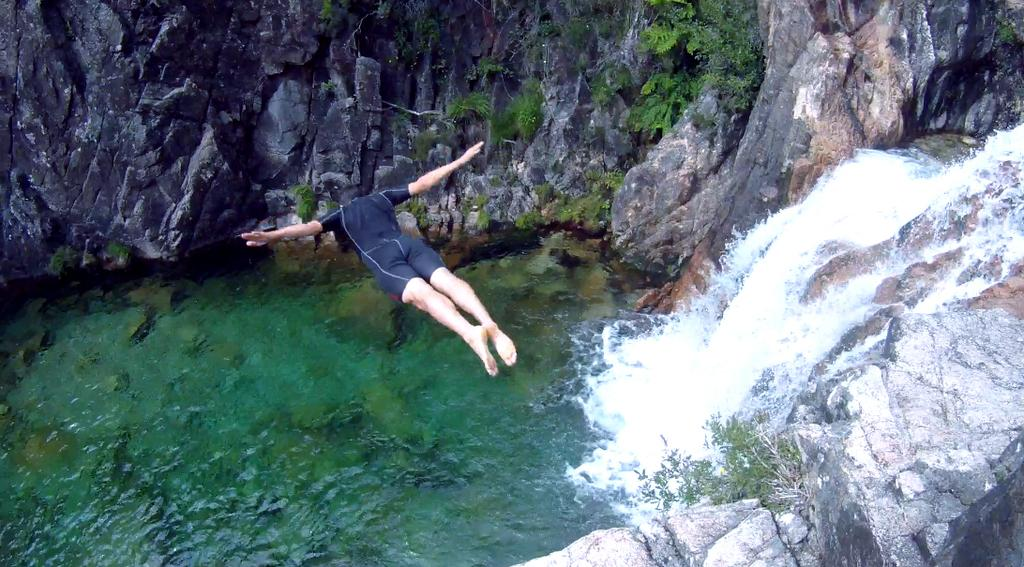What natural feature is the main subject of the image? There is a waterfall in the image. What type of geological formation can be seen in the image? Rocks are present in the image. What type of vegetation is visible in the image? Plants and grass are present in the image. What is the person in the image doing? There is a person jumping in the image. What type of print can be seen on the person's clothing in the image? There is no information about the person's clothing or any prints on it in the provided facts. 